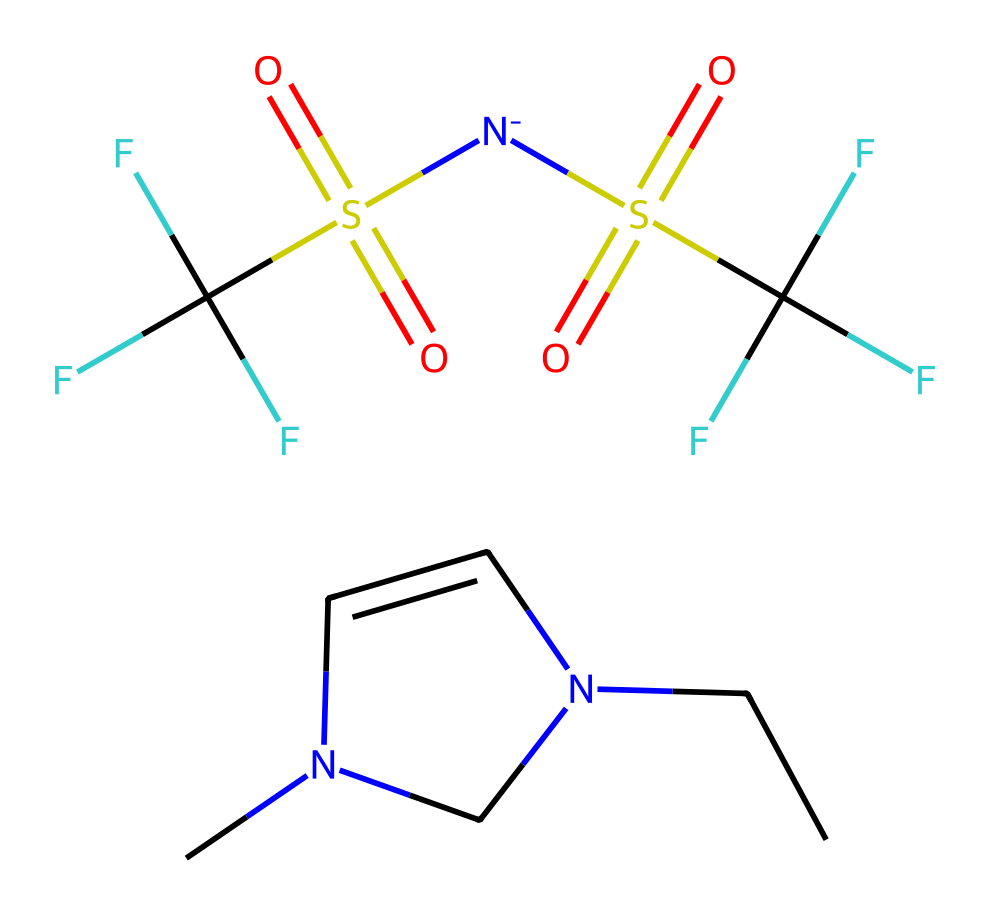What are the main components of this ionic liquid? The SMILES notation reveals two main parts: a cation (the nitrogen-containing cyclic structure) and an anion (the sulfonyl fluoride groups and trifluoromethyl groups).
Answer: cation and anion How many nitrogen atoms are present in this structure? The SMILES representation indicates there are two nitrogen atoms, one in the cyclic structure of the cation and one in the anion part.
Answer: two What type of ionic interactions are likely present in this ionic liquid? Ionic liquids typically have strong ionic interactions due to the cation-anion pairing, specifically the electrostatic attractions between the positively charged nitrogen in the cation and the negatively charged sulfonate groups in the anion.
Answer: ionic interactions What functional groups are present in this ionic liquid? Analyzing the structure presents functional groups such as the sulfonate group (S(=O)(=O)) and trifluoromethyl groups (C(F)(F)F), which are indicative of its ionic and stability characteristics.
Answer: sulfonate and trifluoromethyl Is this ionic liquid hydrophilic or hydrophobic? Considering the presence of multiple fluorine atoms and the sulfonate groups, which tend to repel water, this ionic liquid has characteristics that are more hydrophobic than hydrophilic.
Answer: hydrophobic How many total carbon atoms are in this ionic liquid? By counting the carbon atoms present in both the cation and anion from the SMILES structure, there are five carbon atoms in total.
Answer: five 